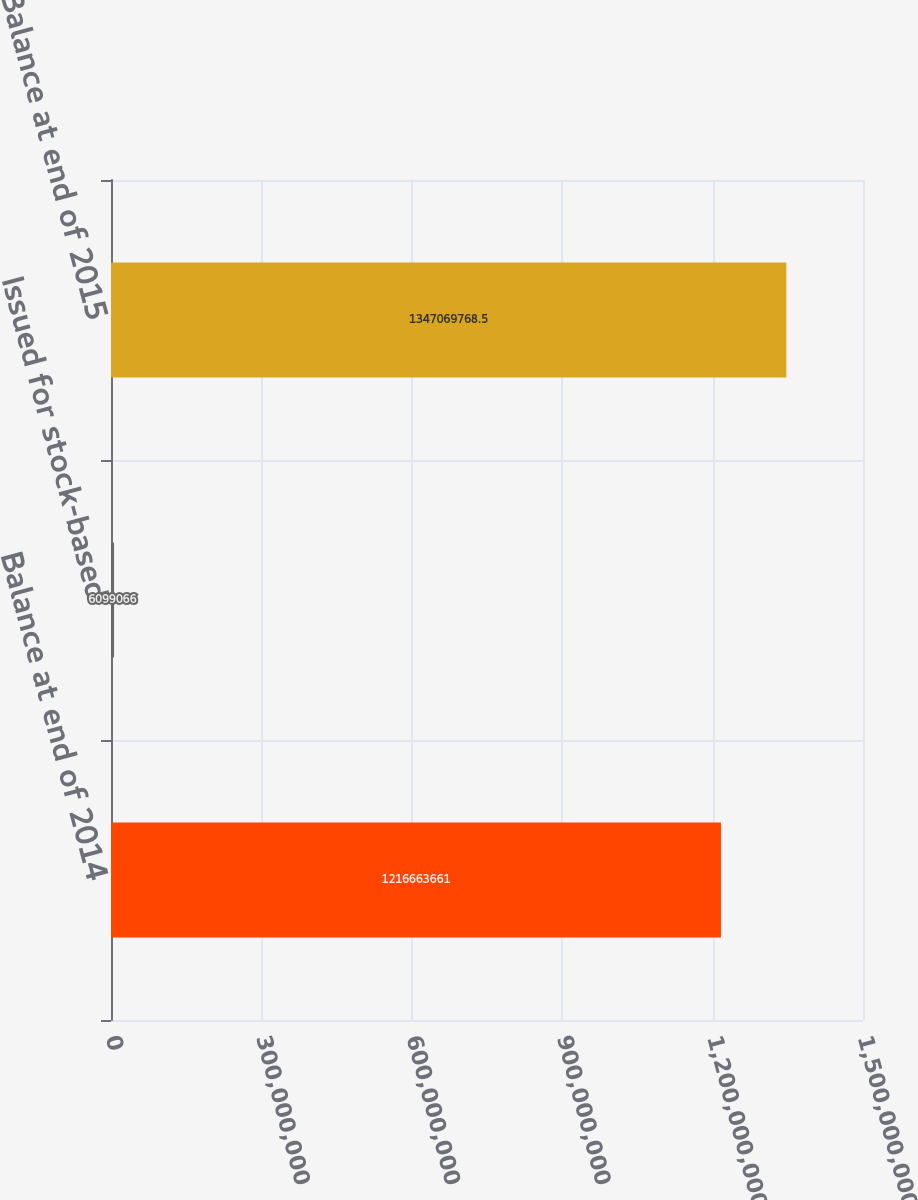Convert chart to OTSL. <chart><loc_0><loc_0><loc_500><loc_500><bar_chart><fcel>Balance at end of 2014<fcel>Issued for stock-based<fcel>Balance at end of 2015<nl><fcel>1.21666e+09<fcel>6.09907e+06<fcel>1.34707e+09<nl></chart> 